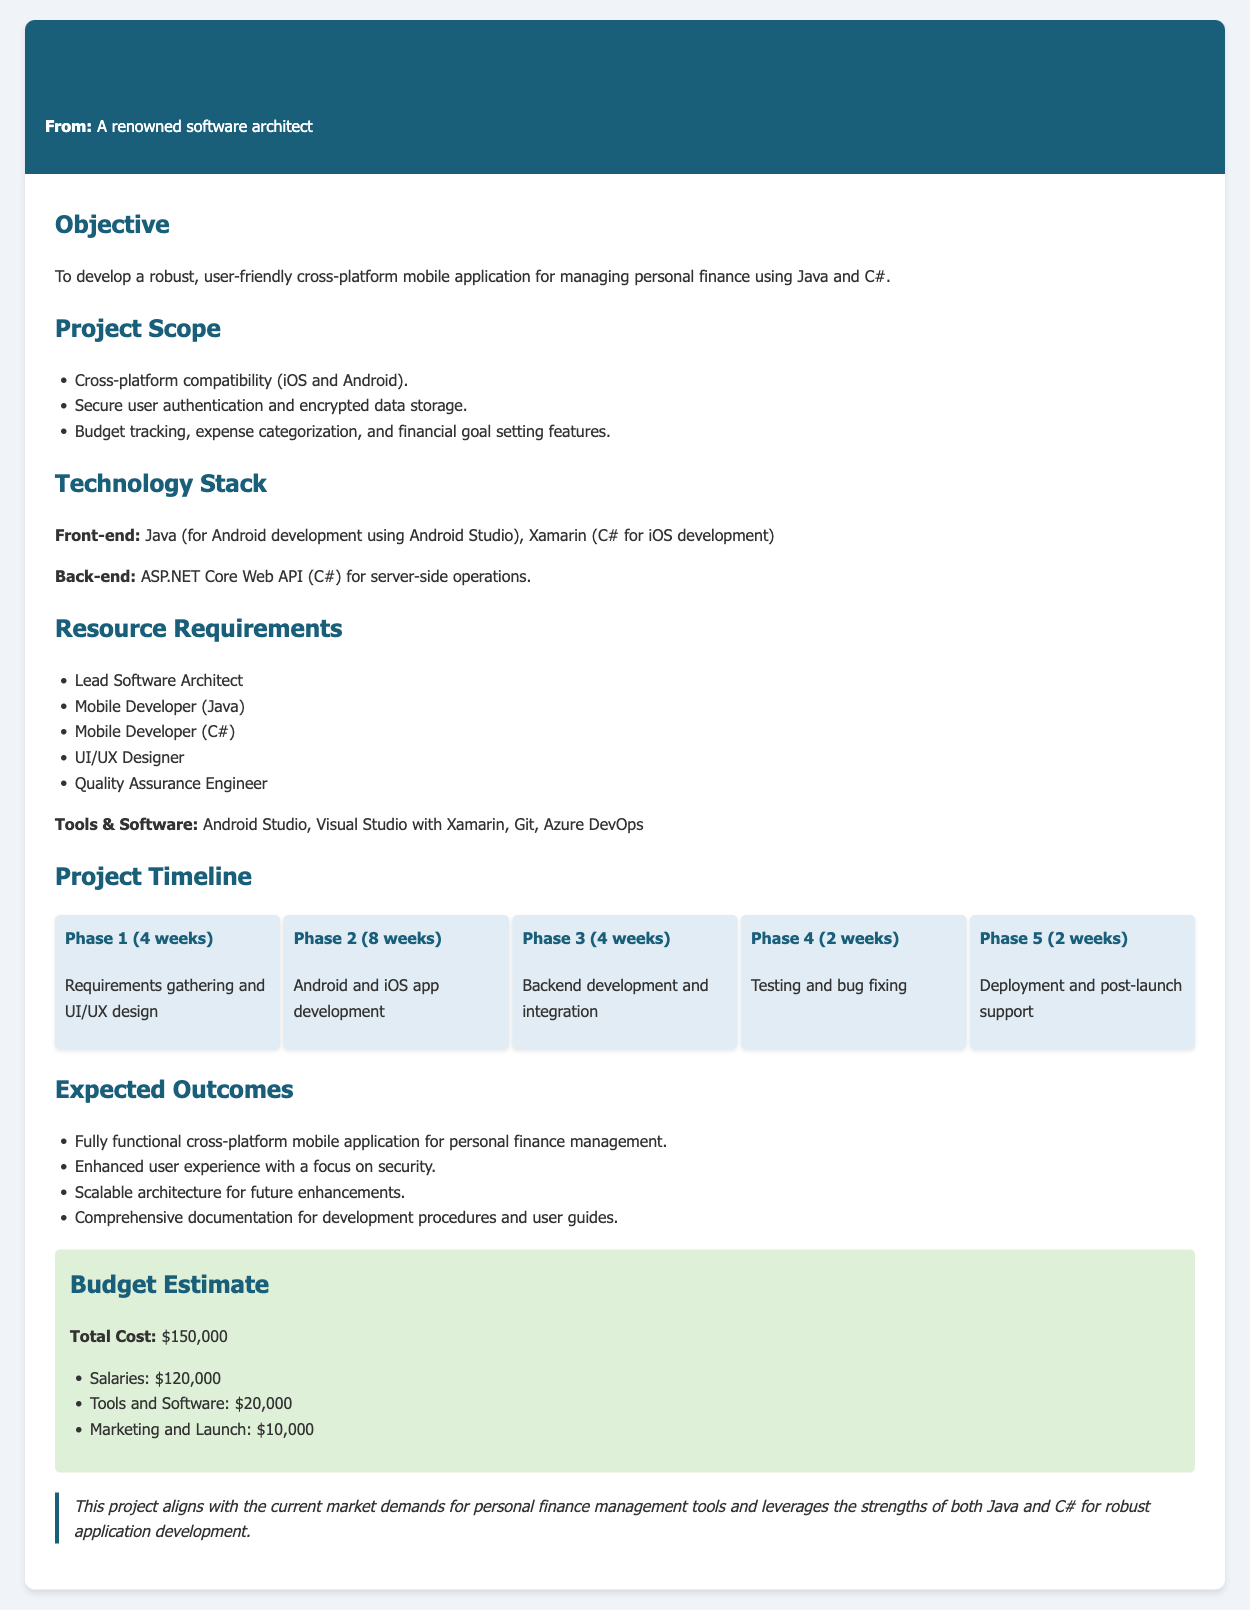What is the objective of the project? The objective is to develop a robust, user-friendly cross-platform mobile application for managing personal finance using Java and C#.
Answer: To develop a robust, user-friendly cross-platform mobile application for managing personal finance using Java and C# Who is the lead mobile developer? The document specifies a Mobile Developer (Java) and a Mobile Developer (C#) but does not name individuals.
Answer: Unknown How long is the testing phase? The document states that the testing and bug fixing phase lasts for 2 weeks.
Answer: 2 weeks What is the estimated total cost of the project? The total cost is explicitly mentioned in the budget estimate section of the document.
Answer: $150,000 Which tools are required for the project? The document lists the necessary tools and software for the project, including Android Studio and Visual Studio with Xamarin.
Answer: Android Studio, Visual Studio with Xamarin, Git, Azure DevOps What features are included in the project scope? The project scope includes features such as secure user authentication and encrypted data storage.
Answer: Secure user authentication and encrypted data storage How many phases are outlined in the project timeline? The project timeline includes five phases as detailed in the document.
Answer: Five phases What is the expected outcome regarding user experience? The expected outcome emphasizes enhanced user experience with a focus on security.
Answer: Enhanced user experience with a focus on security 